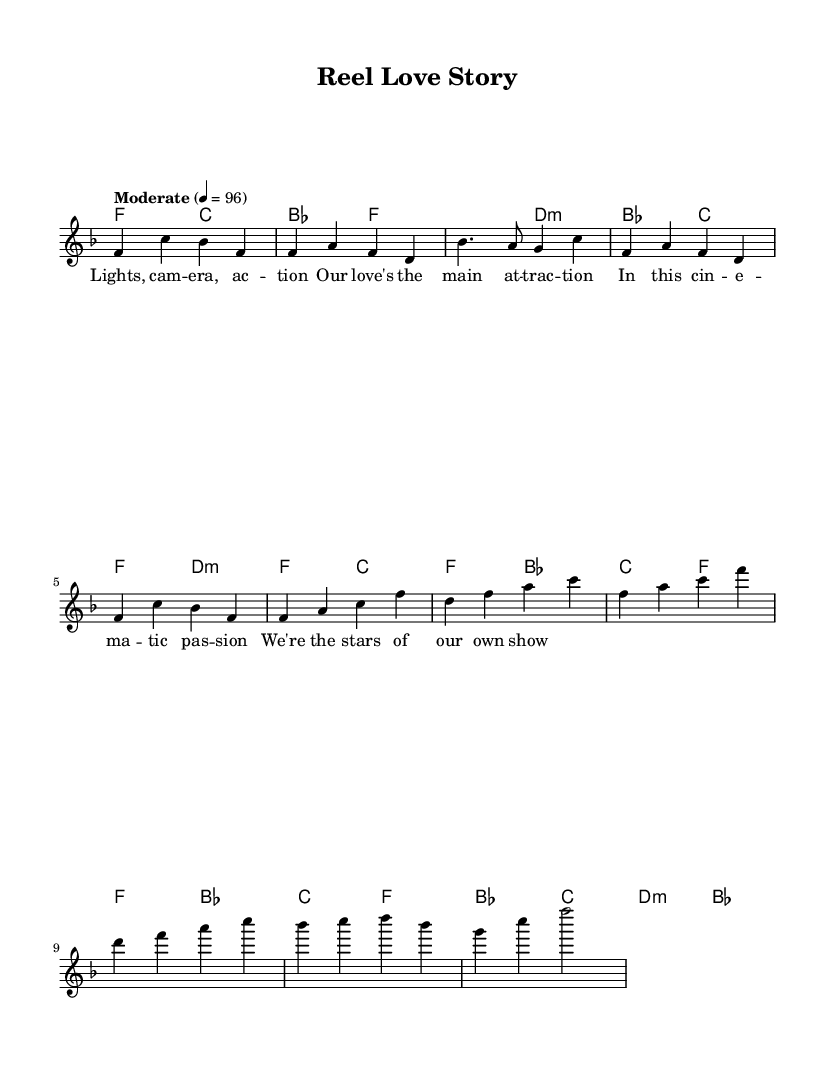What is the key signature of this music? The key signature is F major, which has one flat (B flat). This can be determined by looking at the key signature at the beginning of the music.
Answer: F major What is the time signature of this music? The time signature is 4/4, which can be identified by looking at the time signature indicated on the music sheet.
Answer: 4/4 What is the tempo marking for this music? The tempo marking is "Moderate" at a speed of 96 beats per minute, as shown at the beginning of the score.
Answer: Moderate 4 = 96 How many measures are in the chorus section? The chorus section has four measures, which can be counted by looking at the notation for the chorus in the score.
Answer: 4 What type of chords are used in the bridge? The bridge features major and minor chords, specifically B flat major, C major, and D minor, identifiable from the chord symbols provided.
Answer: Major and minor How does the structure of this piece reflect classic Motown soul elements? The structure includes a clear verse-chorus format, common in Motown soul music, with lyrical storytelling that aligns with the themes of love and relationships, indicative of the genre's narrative focus.
Answer: Verse-chorus format What narrative theme does the lyric snippet suggest? The lyric snippet suggests a theme of romantic love and cinematic storytelling, which is characteristic of the emotional and dramatic elements found in Motown music.
Answer: Romantic love 